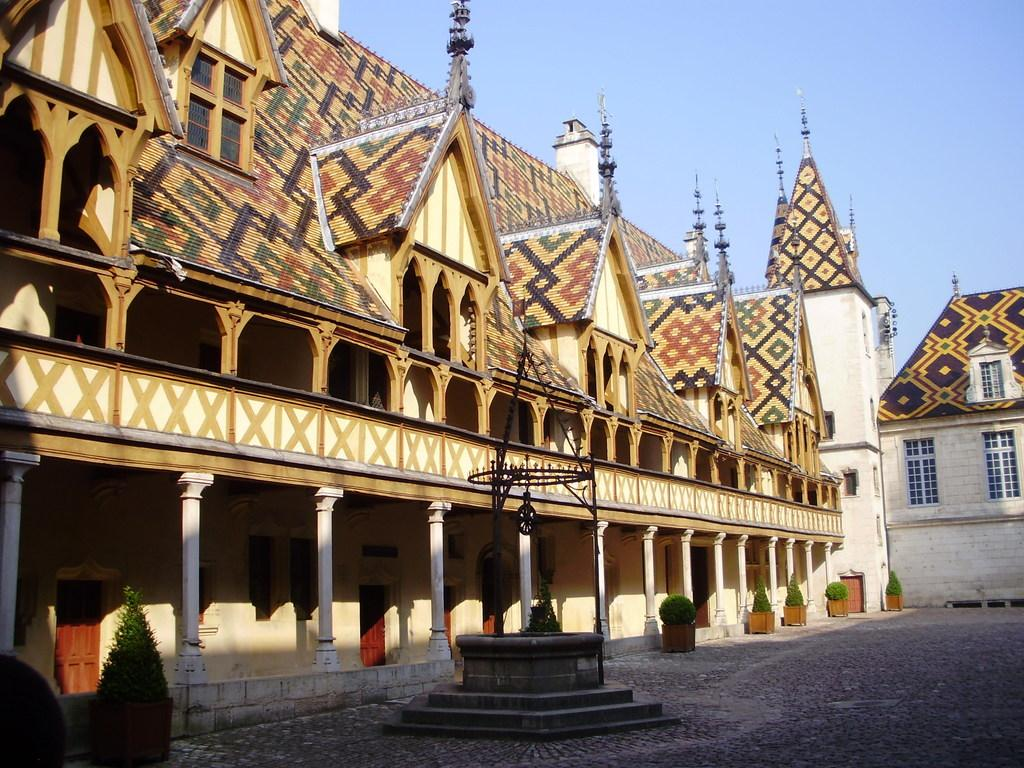What type of surface can be seen in the image? There is ground visible in the image. What architectural feature is present in the image? There are stairs in the image. What type of vegetation is in the image? There are green plants in the image. What type of man-made structures are in the image? There are buildings in the image. What is visible in the background of the image? The sky is visible in the background of the image. Can you tell me how many properties are for sale in the image? There is no information about properties for sale in the image. What type of river can be seen in the image? There is no river present in the image. 